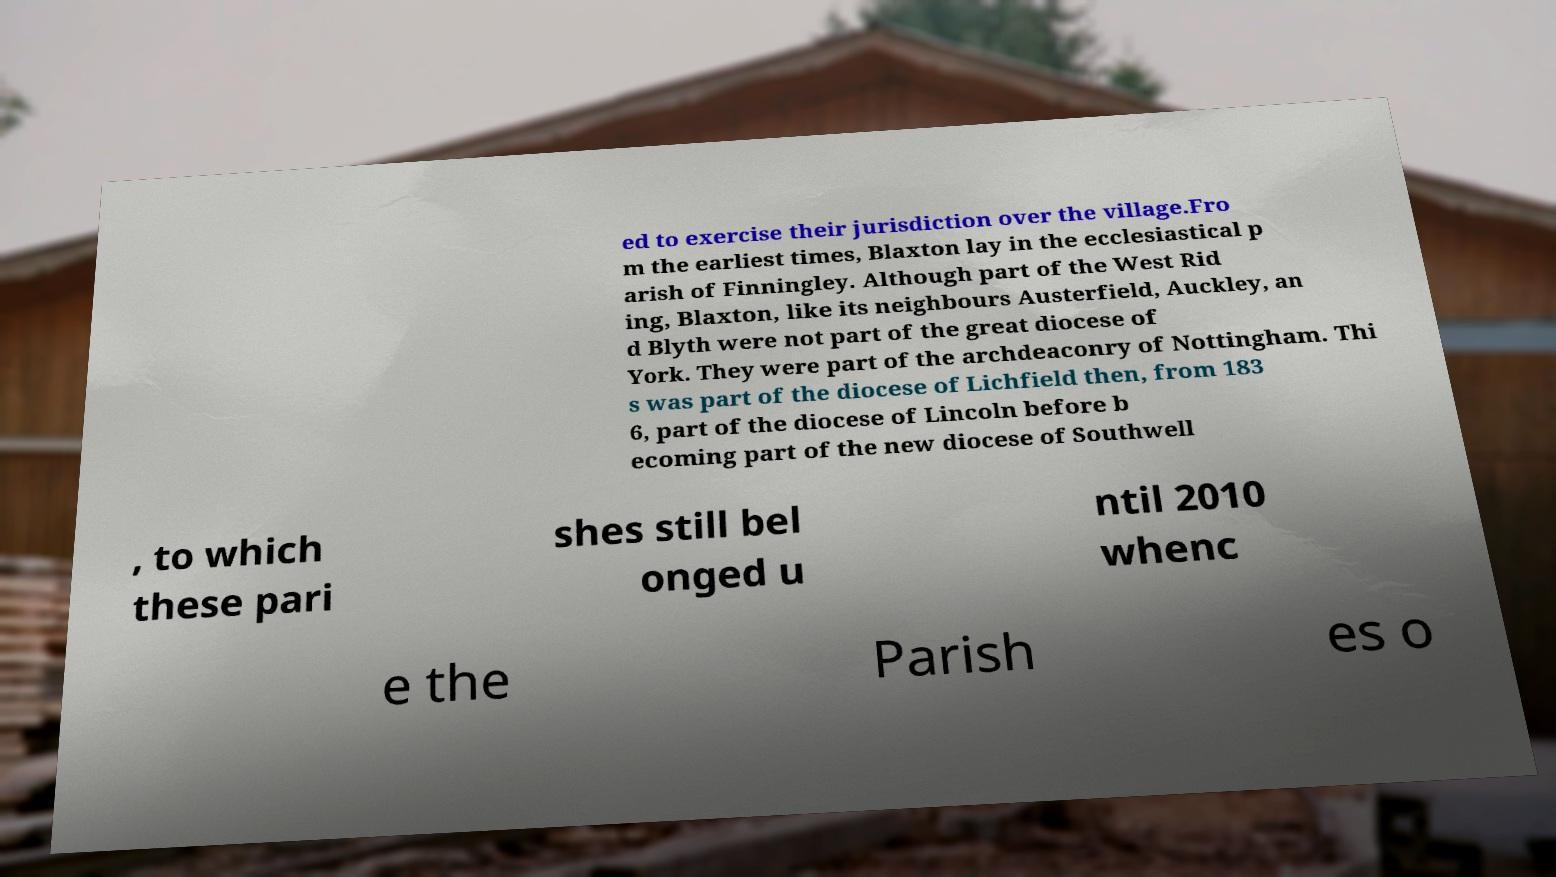I need the written content from this picture converted into text. Can you do that? ed to exercise their jurisdiction over the village.Fro m the earliest times, Blaxton lay in the ecclesiastical p arish of Finningley. Although part of the West Rid ing, Blaxton, like its neighbours Austerfield, Auckley, an d Blyth were not part of the great diocese of York. They were part of the archdeaconry of Nottingham. Thi s was part of the diocese of Lichfield then, from 183 6, part of the diocese of Lincoln before b ecoming part of the new diocese of Southwell , to which these pari shes still bel onged u ntil 2010 whenc e the Parish es o 